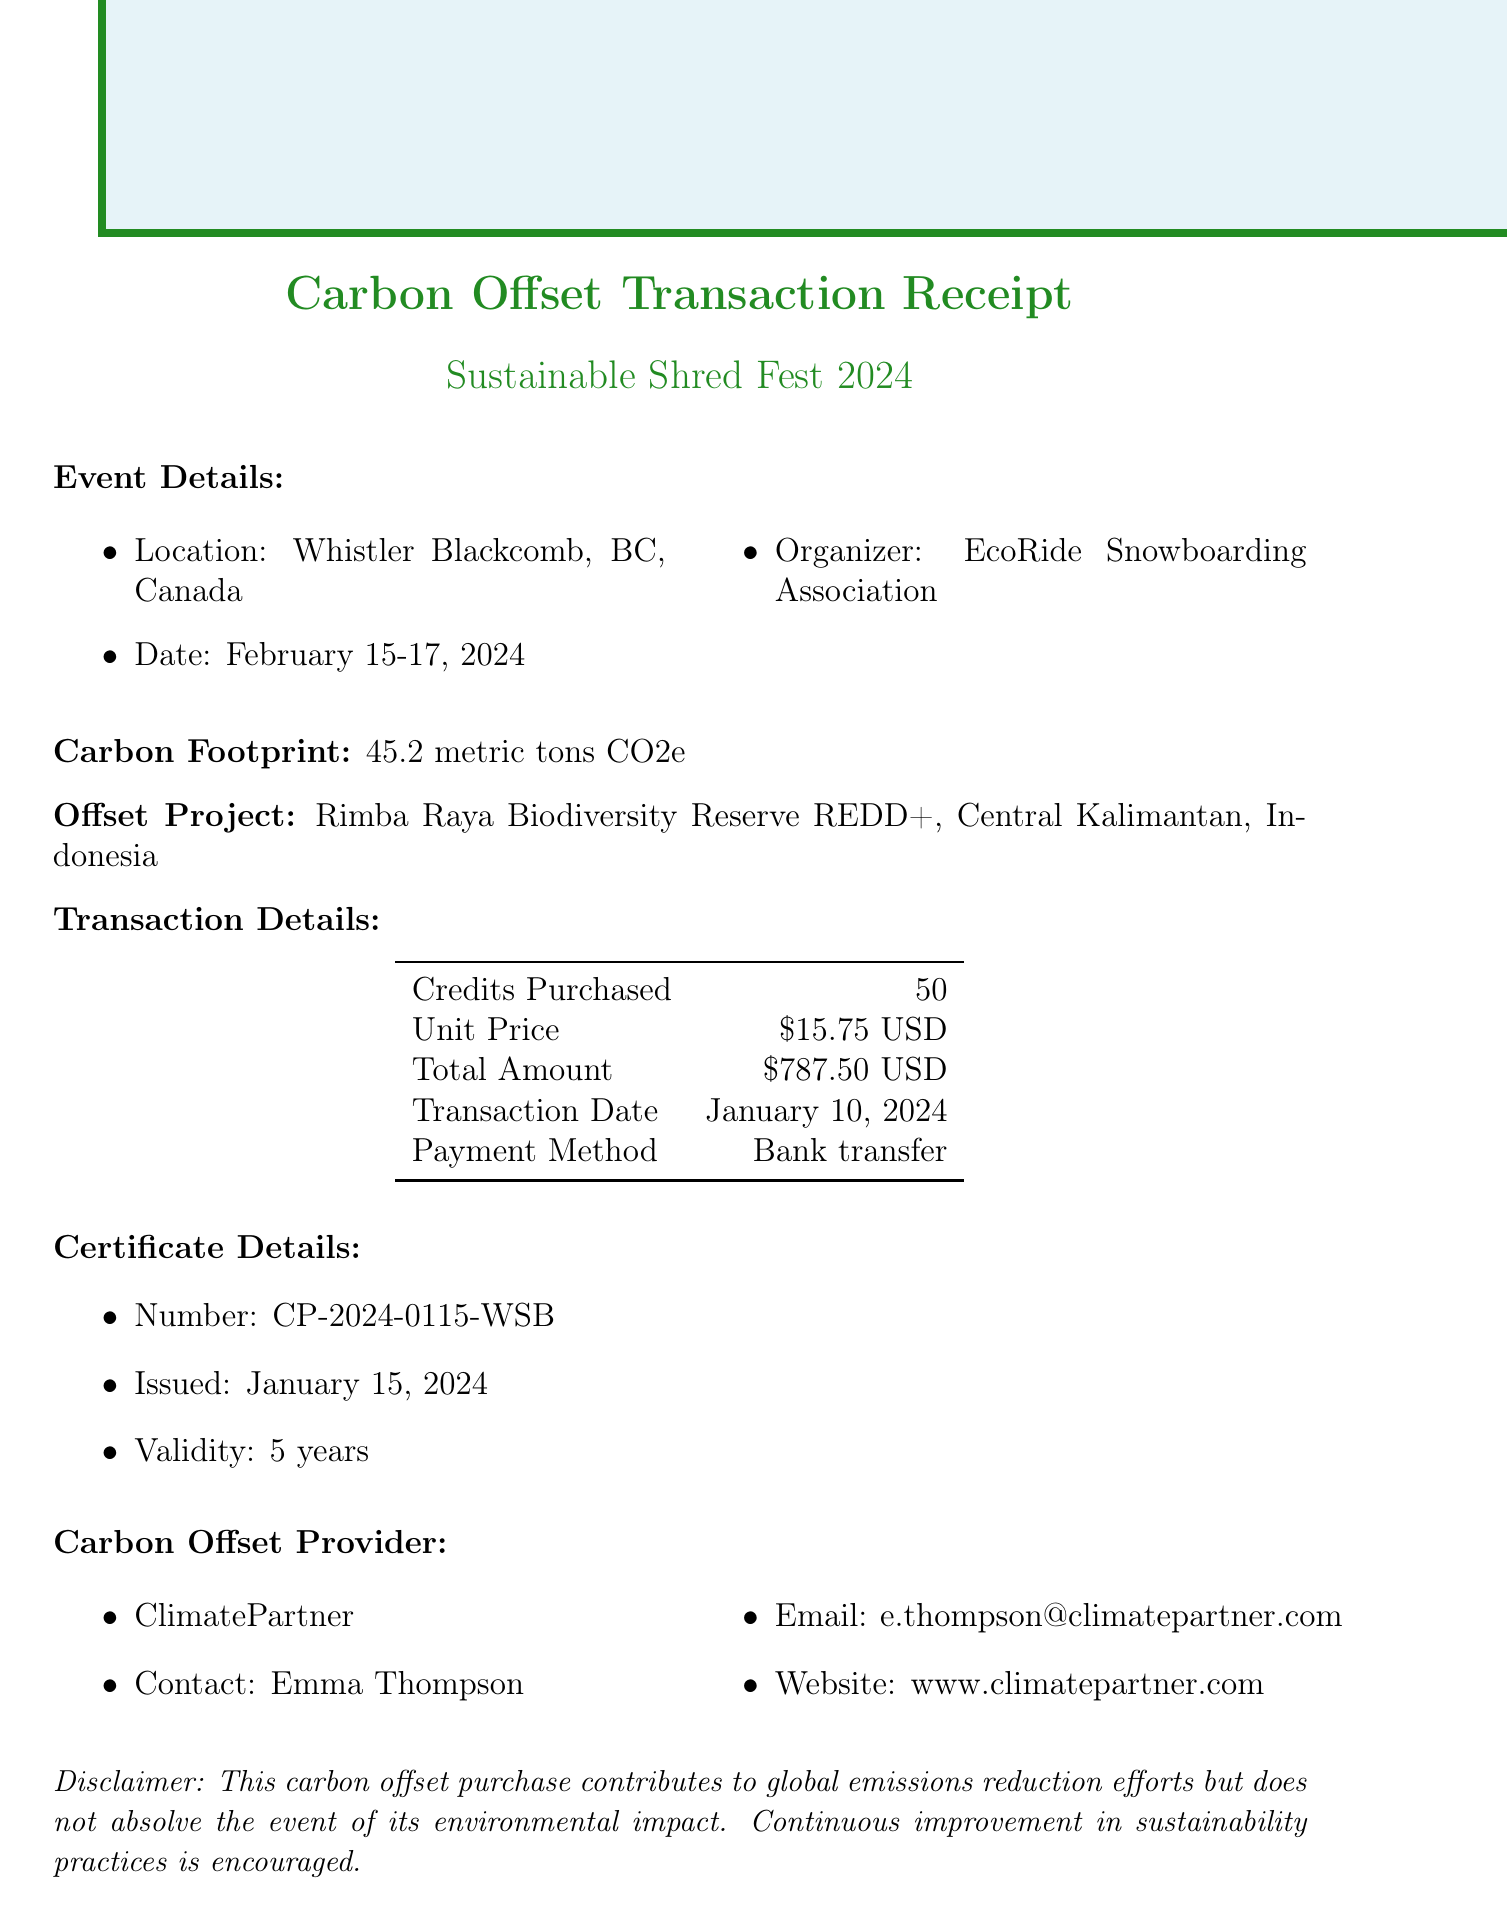What is the event name? The event name is clearly stated in the document as the title of the event details section.
Answer: Sustainable Shred Fest 2024 What is the total amount paid for carbon offset credits? The total amount is specified under the transaction details section of the document.
Answer: 787.50 USD When was the transaction date? The transaction date is presented as part of the transaction details.
Answer: January 10, 2024 How many carbon offset credits were purchased? The number of credits purchased is listed in the transaction details of the document.
Answer: 50 What is the validity period of the carbon offset certificate? The validity period is mentioned in the certificate details section.
Answer: 5 years Who is the contact person for the carbon offset provider? The contact person is noted under the carbon offset provider section.
Answer: Emma Thompson What is the total emissions calculated for the event? The total emissions are stated in the carbon footprint section of the document.
Answer: 45.2 metric tons CO2e What type of offset project is specified? The type of offset project is detailed under the offset project section in the document.
Answer: Forest Conservation What is the URL for the carbon-neutral logo? The URL for the carbon-neutral logo is provided in the additional info section of the document.
Answer: https://www.climatepartner.com/en/carbon-neutral-label 